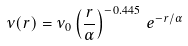<formula> <loc_0><loc_0><loc_500><loc_500>\nu ( r ) = \nu _ { 0 } \left ( \frac { r } { \alpha } \right ) ^ { - 0 . 4 4 5 } \, e ^ { - r / \alpha }</formula> 